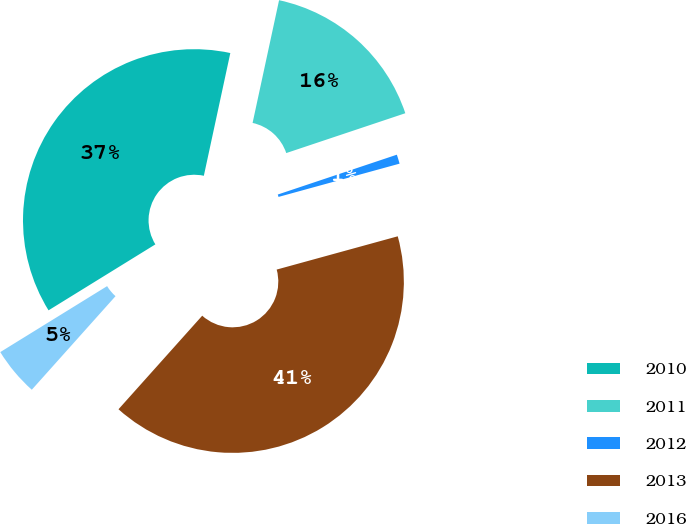<chart> <loc_0><loc_0><loc_500><loc_500><pie_chart><fcel>2010<fcel>2011<fcel>2012<fcel>2013<fcel>2016<nl><fcel>37.19%<fcel>16.48%<fcel>0.87%<fcel>40.89%<fcel>4.58%<nl></chart> 